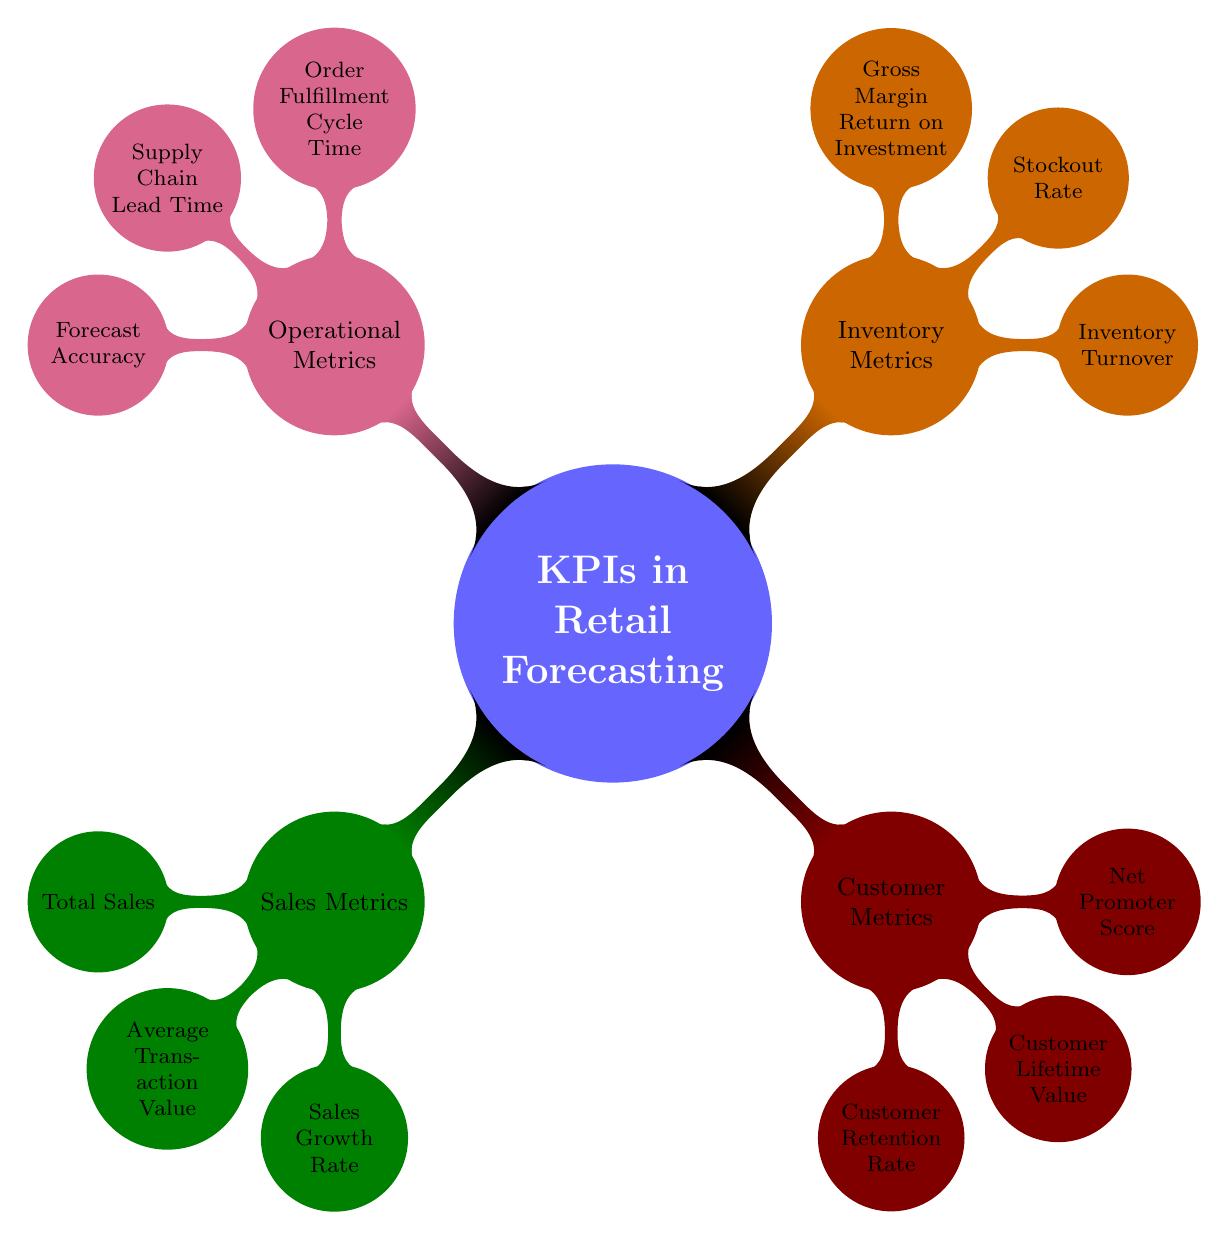What is the main topic of the diagram? The diagram is centered around the concept of KPIs in Retail Forecasting, which serves as the primary focus from which all other nodes branch.
Answer: KPIs in Retail Forecasting How many main subtopics are represented in the diagram? There are four main subtopics branching from the central topic: Sales Metrics, Customer Metrics, Inventory Metrics, and Operational Metrics.
Answer: 4 What is one example of a Sales Metric? The diagram includes Total Sales as one specific metric under the Sales Metrics category, which is related to revenue from transactions.
Answer: Total Sales Which metric measures customer loyalty and satisfaction? Among the Customer Metrics, the Net Promoter Score is specifically identified as the measurement that evaluates customer loyalty and satisfaction levels.
Answer: Net Promoter Score What relationship exists between Inventory Metrics and Sales Metrics? While the diagram does not depict a direct connection or causation between Inventory Metrics and Sales Metrics, both represent essential metrics that impact overall retail performance in forecasting.
Answer: None Which operational metric assesses the accuracy of sales forecasts? The Forecast Accuracy metric under Operational Metrics focuses on evaluating how well sales forecasts reflect actual sales results.
Answer: Forecast Accuracy What does the Stockout Rate measure? Within Inventory Metrics, the Stockout Rate describes the frequency at which the inventory runs out of stock, indicating how often items are unavailable for purchase.
Answer: Frequency of inventory running out of stock How many metrics are listed under Customer Metrics? There are three metrics detailed under Customer Metrics: Customer Retention Rate, Customer Lifetime Value, and Net Promoter Score, indicating a focus on different aspects of customer engagement.
Answer: 3 What is the purpose of the GMROI metric? GMROI, listed in Inventory Metrics, serves as a profitability ratio analyzing how effectively inventory invests return a profit, linking inventory management to financial performance.
Answer: Profitability ratio analyzing inventory profit return 